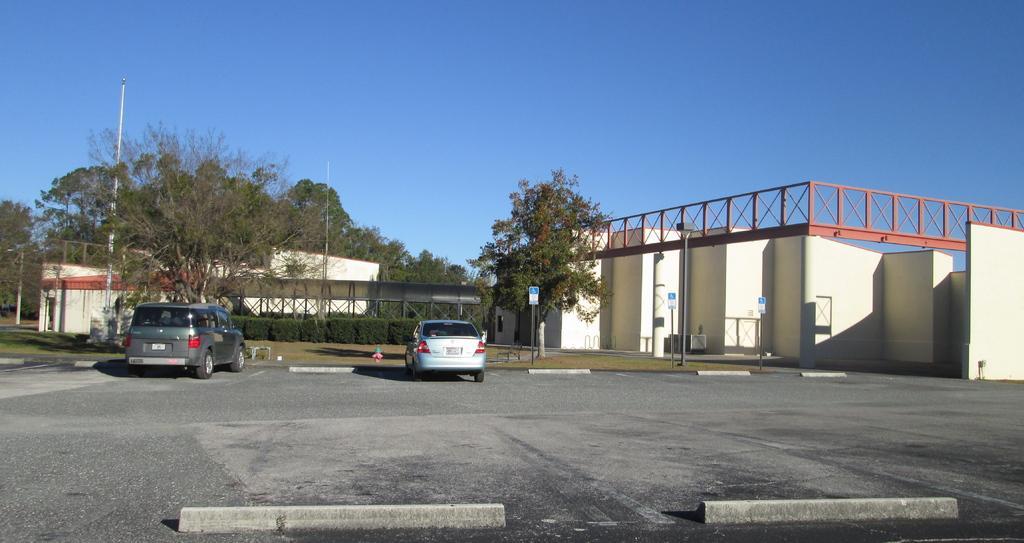Can you describe this image briefly? There are two cars on the road. This is grass and there are plants. Here we can see poles, boards, trees, and houses. In the background there is sky. 